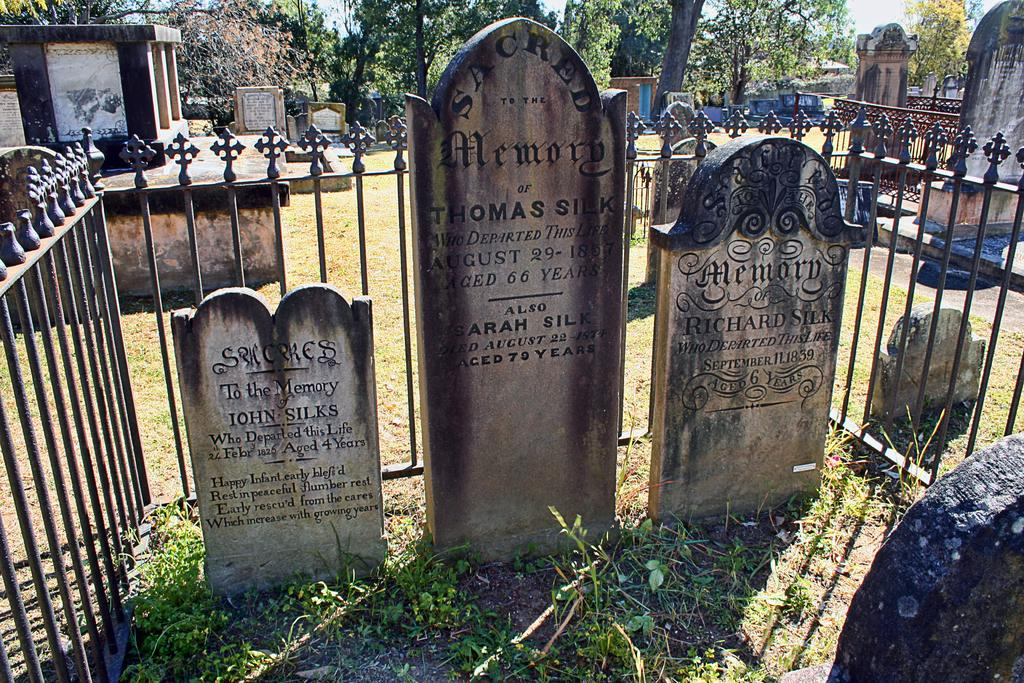What type of objects can be seen in the image? There are headstones and iron grilles in the image. What can be seen in the background of the image? There are trees in the background of the image. What is the afterthought of the person who designed the headstones in the image? There is no information about the designer's afterthought in the image, as it only shows the headstones and iron grilles. How does the person in the image grip the iron grilles? There is no person present in the image, so it is impossible to determine how they might grip the iron grilles. 